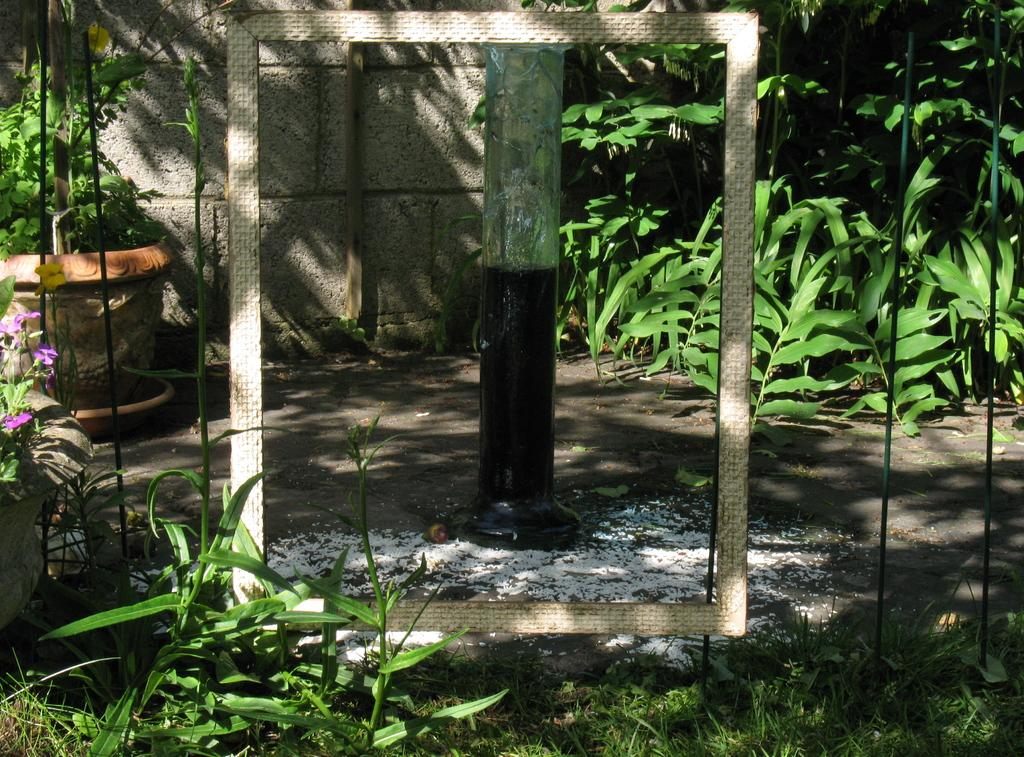What type of vegetation can be seen in the image? There are plants and grass in the image. Are there any flowers visible in the image? Yes, there are flowers in a pot in the image. What is the frame in the image used for? The purpose of the frame in the image is not clear, but it could be decorative or functional. What might be the cause of the food fallen on the ground in the image? The food could have been dropped or spilled accidentally. What is the pole in the image used for? The purpose of the pole in the image is not clear, but it could be for support, signage, or decoration. What is the wall in the image made of? The material of the wall in the image is not clear, but it could be brick, concrete, or another material. Can you suggest a squirrel to roll the food back onto the plate in the image? There is no squirrel present in the image, and therefore it cannot be suggested to roll the food back onto the plate. 